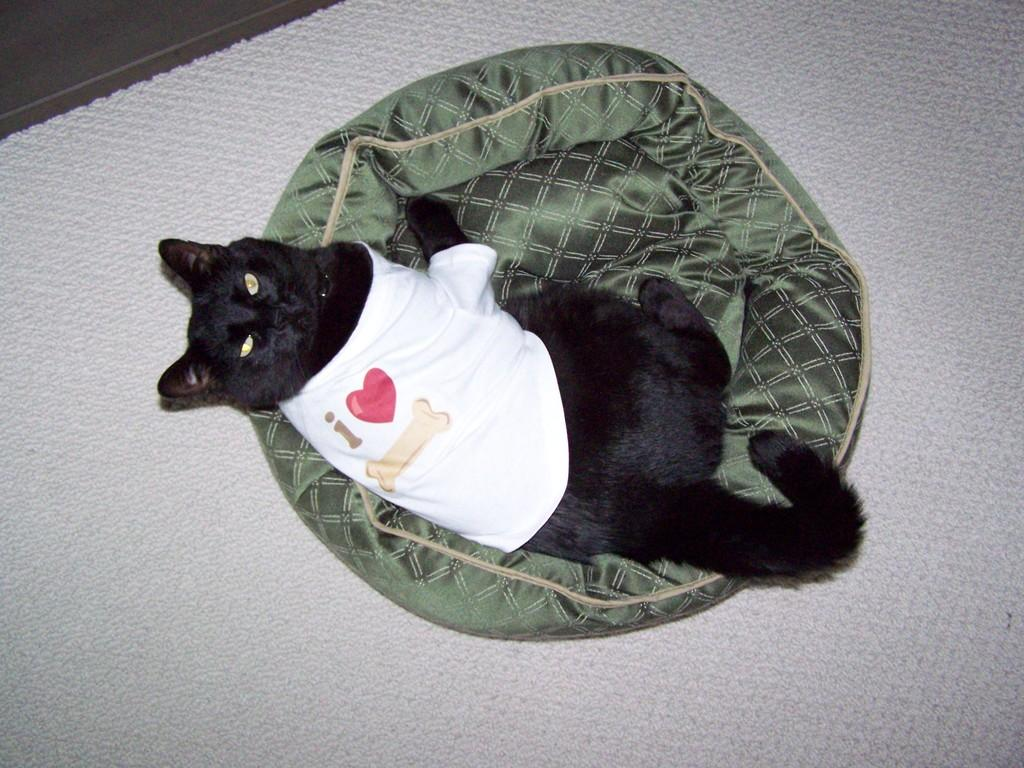What type of animal is in the image? There is a black color cat in the image. What is the cat doing in the image? The cat is lying on an object. What color are the clothes the cat is wearing? The cat is wearing white color clothes. What color is the surface visible in the image? There is a white color surface in the image. How many dimes can be seen on the cat's tail in the image? There are no dimes present in the image, and the cat's tail is not visible. 